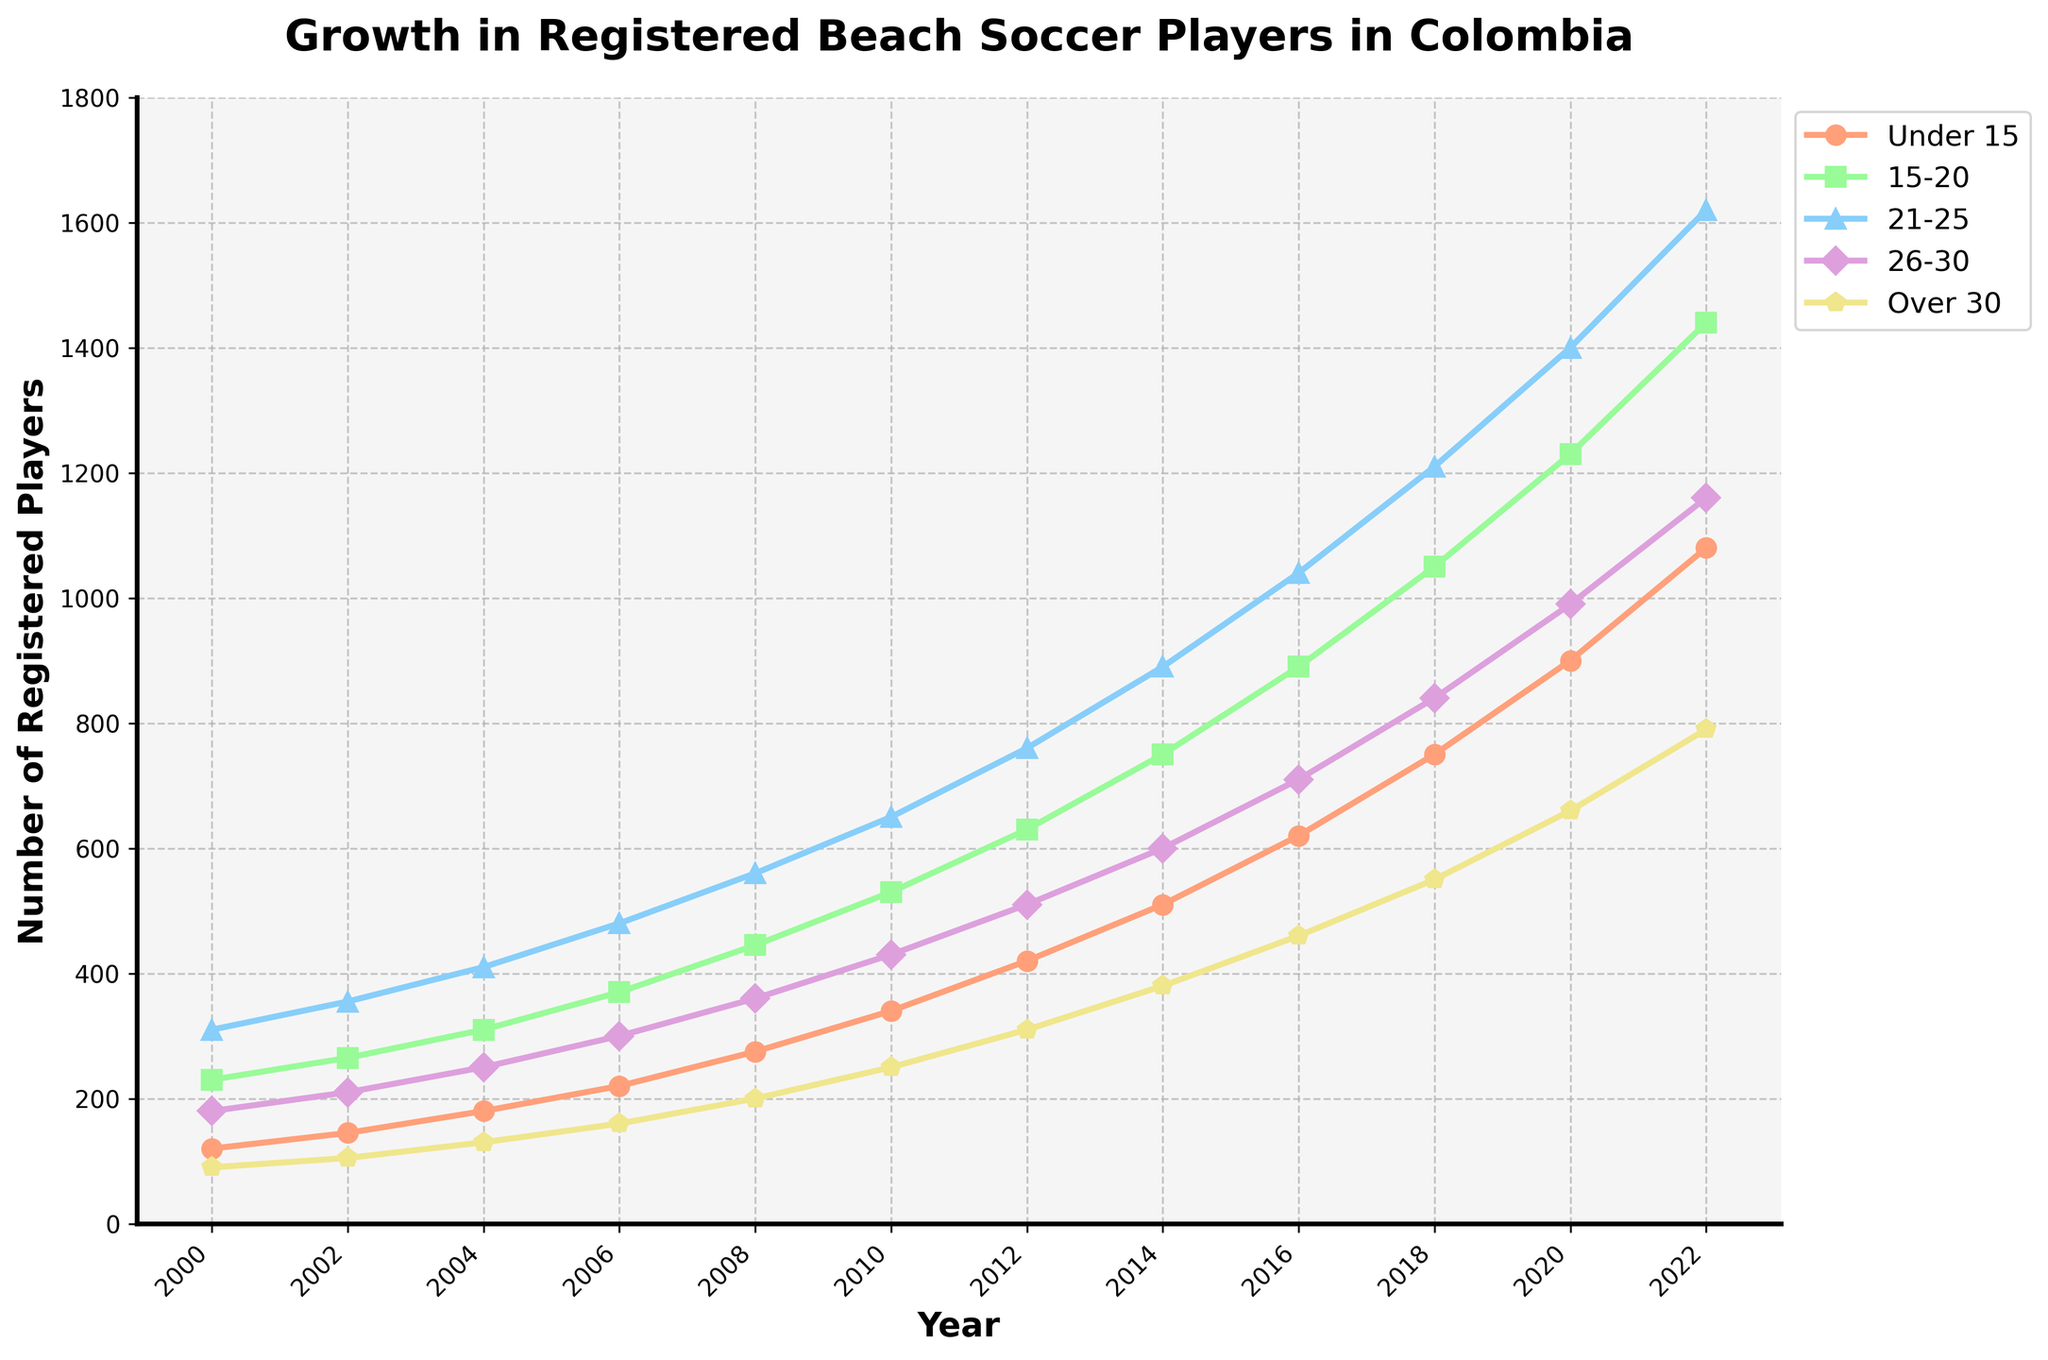What age group experienced the highest growth in registered players from 2000 to 2022? First, identify the number of players in each age group in 2000 and 2022. Calculate the difference for each group. The "Under 15" group grew from 120 to 1080, a difference of 960. The "15-20" group grew from 230 to 1440, a difference of 1210. The "21-25" group grew from 310 to 1620, a difference of 1310. The "26-30" group grew from 180 to 1160, a difference of 980. The "Over 30" group grew from 90 to 790, a difference of 700. The group with the highest growth is "21-25" with a growth of 1310 players.
Answer: 21-25 Which age group had the highest number of registered players in 2012? Look at the data points for each age group in 2012. "Under 15" had 420, "15-20" had 630, "21-25" had 760, "26-30" had 510, and "Over 30" had 310. The "21-25" age group had the highest number with 760 registered players.
Answer: 21-25 In which year did the "26-30" age group surpass 600 registered players? Identify the data points for the "26-30" age group in each year. The number of registered players is 180 in 2000, 210 in 2002, 250 in 2004, 300 in 2006, 360 in 2008, 430 in 2010, 510 in 2012, 600 in 2014, and 710 in 2016. The "26-30" age group surpassed 600 registered players in 2016.
Answer: 2016 Compare the number of registered players for the "Over 30" age group in 2000 and 2022. By what percentage did it increase? Calculate the difference in the number of registered players in the "Over 30" group between 2000 (90) and 2022 (790). The difference is 700. The percentage increase is (700/90) * 100 = 777.78%.
Answer: 777.78% What is the average number of registered players in the "Under 15" age group for the years 2000, 2004, 2008, and 2012? Find the number of registered players in the "Under 15" group for the specified years: 120 in 2000, 180 in 2004, 275 in 2008, and 420 in 2012. Add these numbers: 120 + 180 + 275 + 420 = 995. Divide by the number of years (4): 995 / 4 = 248.75.
Answer: 248.75 How does the growth in the number of players in the "Under 15" group compare to the "Over 30" group from 2000 to 2010? Calculate the difference in the number of players for both age groups between 2000 and 2010. "Under 15" grew from 120 in 2000 to 340 in 2010, with a growth of 220. "Over 30" grew from 90 in 2000 to 250 in 2010, with a growth of 160. The growth in the "Under 15" group (220 players) is greater than in the "Over 30" group (160 players).
Answer: Greater What trend can be observed for the "15-20" age group from 2000 to 2022? Observe the number of registered players in the "15-20" group each year. The numbers are consistently increasing over the years: 230 in 2000, 265 in 2002, 310 in 2004, 370 in 2006, 445 in 2008, 530 in 2010, 630 in 2012, 750 in 2014, 890 in 2016, 1050 in 2018, 1230 in 2020, and 1440 in 2022. The trend for this group is continuously upward.
Answer: Upward trend Which two age groups had the closest number of registered players in the year 2006? Look at the data points for each age group in 2006: "Under 15" had 220, "15-20" had 370, "21-25" had 480, "26-30" had 300, and "Over 30" had 160. The closest numbers are between "26-30" (300) and "Under 15" (220), with a difference of 80.
Answer: Under 15 and 26-30 